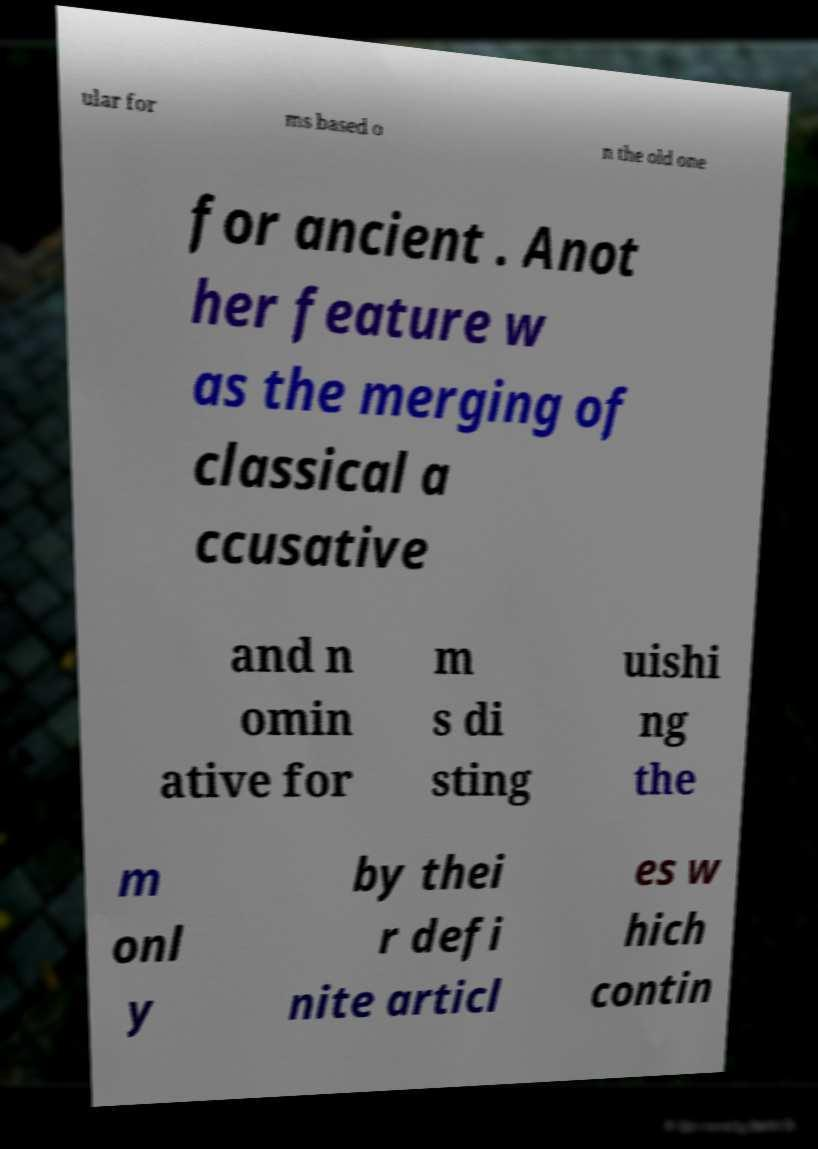Could you assist in decoding the text presented in this image and type it out clearly? ular for ms based o n the old one for ancient . Anot her feature w as the merging of classical a ccusative and n omin ative for m s di sting uishi ng the m onl y by thei r defi nite articl es w hich contin 